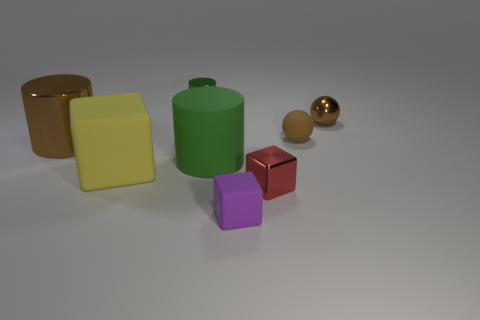The small block to the right of the small matte thing in front of the small metallic cube is what color?
Your answer should be very brief. Red. How many rubber things are behind the brown metallic cylinder and in front of the tiny red metallic block?
Give a very brief answer. 0. How many other small matte things are the same shape as the red thing?
Offer a terse response. 1. Is the material of the large brown cylinder the same as the large green cylinder?
Your answer should be very brief. No. There is a object left of the big object in front of the green rubber cylinder; what shape is it?
Make the answer very short. Cylinder. How many rubber blocks are behind the matte cube that is on the right side of the matte cylinder?
Your answer should be very brief. 1. What material is the thing that is both behind the rubber ball and in front of the small green shiny object?
Your response must be concise. Metal. What shape is the shiny thing that is the same size as the yellow rubber object?
Offer a terse response. Cylinder. There is a sphere on the left side of the shiny sphere that is behind the large thing that is on the right side of the yellow block; what color is it?
Make the answer very short. Brown. How many things are brown objects that are right of the small red cube or large purple rubber objects?
Ensure brevity in your answer.  2. 